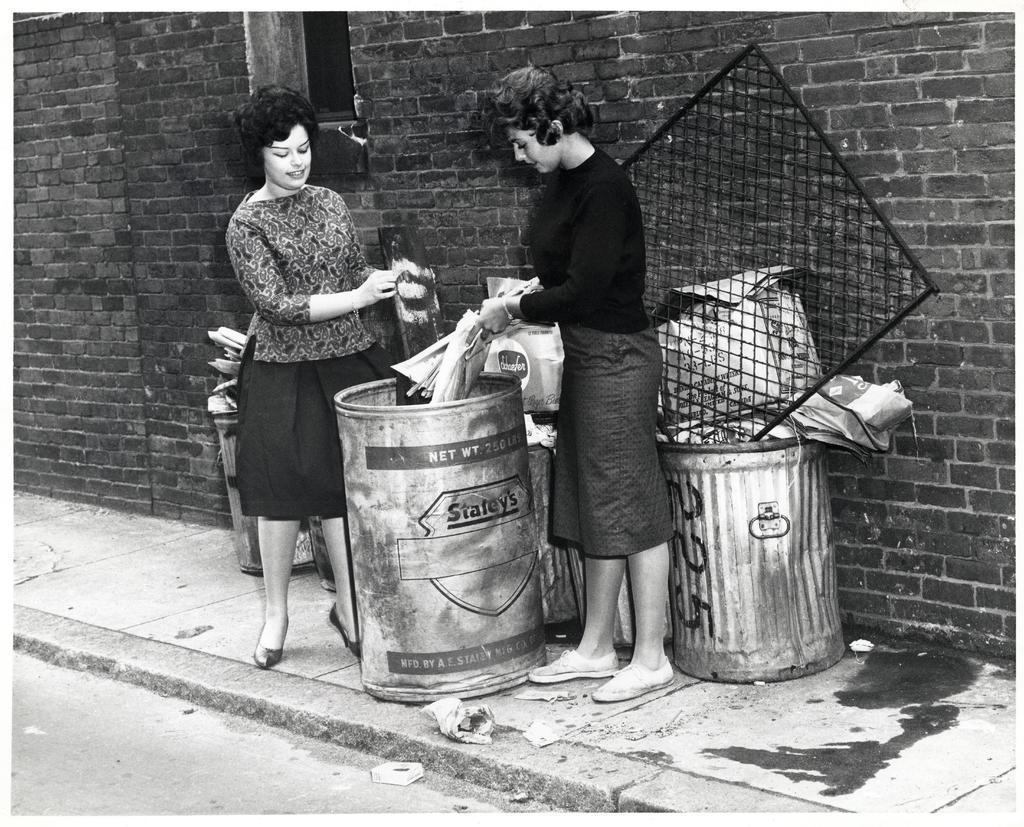<image>
Render a clear and concise summary of the photo. Two women throw items into a drum with a net weight of 250 pounds. 